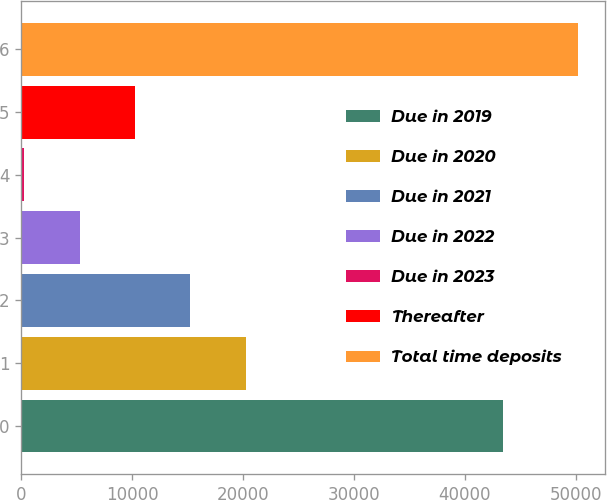Convert chart to OTSL. <chart><loc_0><loc_0><loc_500><loc_500><bar_chart><fcel>Due in 2019<fcel>Due in 2020<fcel>Due in 2021<fcel>Due in 2022<fcel>Due in 2023<fcel>Thereafter<fcel>Total time deposits<nl><fcel>43452<fcel>20224.8<fcel>15236.1<fcel>5258.7<fcel>270<fcel>10247.4<fcel>50157<nl></chart> 